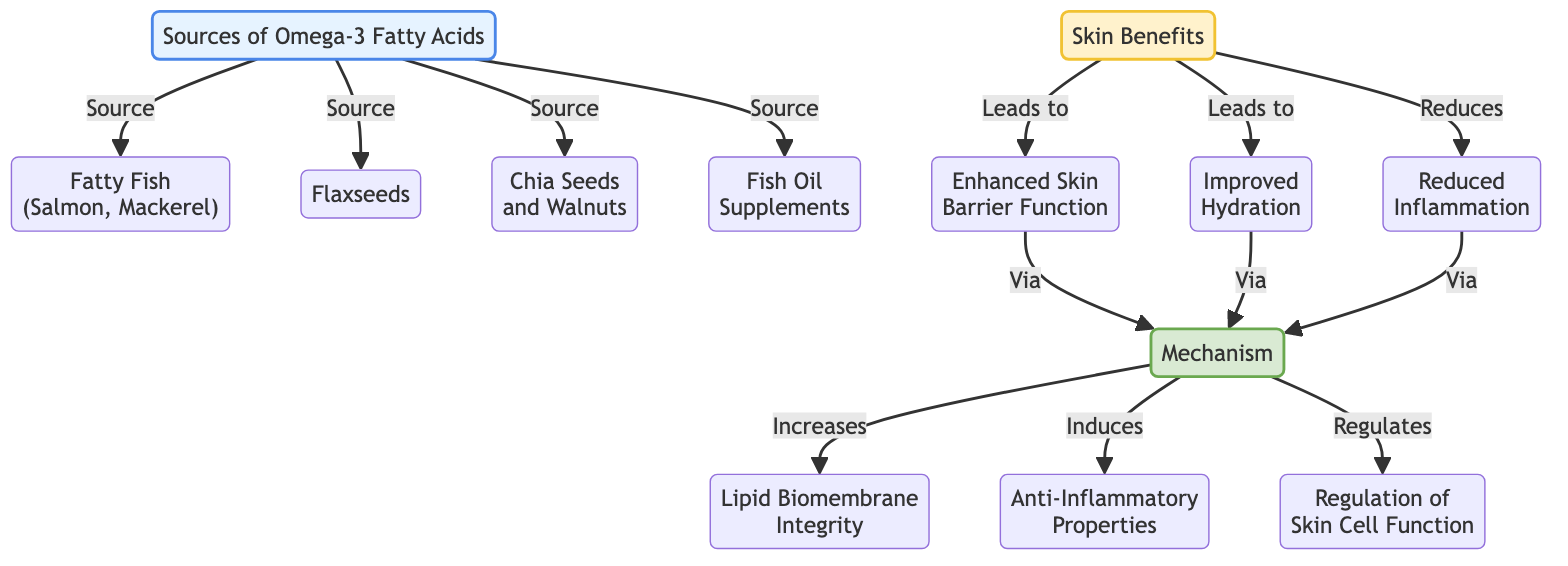What are two sources of Omega-3 fatty acids? The diagram lists several sources of Omega-3 fatty acids. Among them, "Fatty Fish" and "Flaxseeds" are explicitly mentioned as two sources.
Answer: Fatty Fish, Flaxseeds How many skin benefits are listed? The diagram outlines three skin benefits resulting from Omega-3 fatty acids: Enhanced Skin Barrier Function, Improved Hydration, and Reduced Inflammation. Thus, the total count of skin benefits is three.
Answer: 3 What is the mechanism that enhances the skin barrier function? The skin barrier function is enhanced through the "Lipid Biomembrane Integrity" mechanism, as indicated by the flow from Enhanced Skin Barrier Function to Mechanism, and then to Lipid Biomembrane Integrity.
Answer: Lipid Biomembrane Integrity Which benefit is linked to reducing inflammation? The diagram states that Reduced Inflammation is one of the skin benefits that directly correlates with the overall skin benefits from Omega-3 fatty acids.
Answer: Reduced Inflammation What are the two mechanisms listed under the mechanism node? The mechanisms listed under the mechanism node include "Lipid Biomembrane Integrity" and "Anti-Inflammatory Properties". Both of these relate to how Omega-3 fatty acids positively impact skin health.
Answer: Lipid Biomembrane Integrity, Anti-Inflammatory Properties Which source has "Supplements" as part of it? The diagram includes "Fish Oil Supplements" under the Omega-3 sources, classifying it as a source of Omega-3 fatty acids alongside others.
Answer: Fish Oil Supplements What leads to improved hydration according to the diagram? The diagram shows that improved hydration is led by the skin benefits category, which includes various outcomes of Omega-3 fatty acids’ effects on the skin, indicating a direct outcome from the overall skin health benefits of Omega-3s.
Answer: Skin Benefits How is cell regulation connected to the mechanisms listed? The connection is made in the diagram where "Regulation of Skin Cell Function" is one of the outcomes, linked to the overall mechanisms that stem from the benefits conveyed through Omega-3 intake, indicating a multi-faceted impact on skin health.
Answer: Regulation of Skin Cell Function 